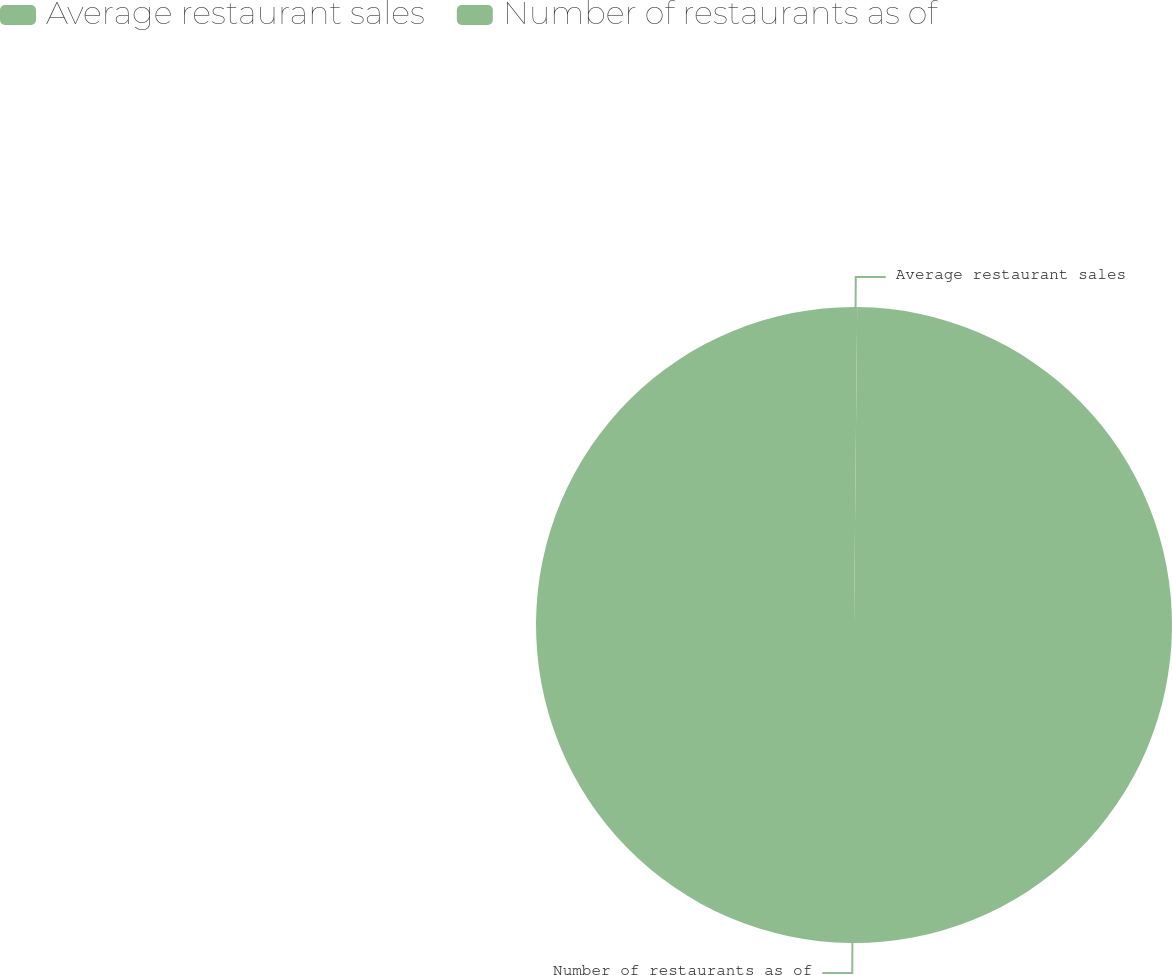Convert chart. <chart><loc_0><loc_0><loc_500><loc_500><pie_chart><fcel>Average restaurant sales<fcel>Number of restaurants as of<nl><fcel>0.16%<fcel>99.84%<nl></chart> 